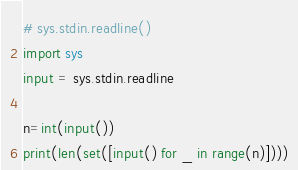Convert code to text. <code><loc_0><loc_0><loc_500><loc_500><_Python_># sys.stdin.readline()
import sys
input = sys.stdin.readline

n=int(input())
print(len(set([input() for _ in range(n)])))</code> 